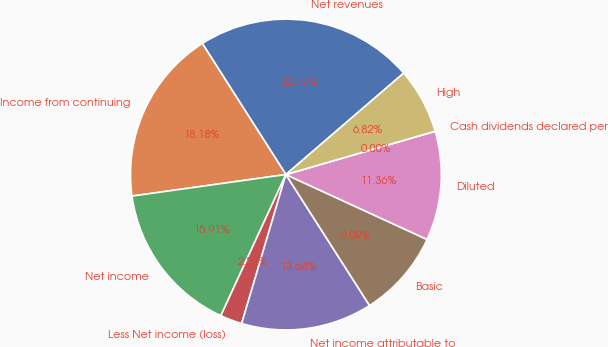Convert chart. <chart><loc_0><loc_0><loc_500><loc_500><pie_chart><fcel>Net revenues<fcel>Income from continuing<fcel>Net income<fcel>Less Net income (loss)<fcel>Net income attributable to<fcel>Basic<fcel>Diluted<fcel>Cash dividends declared per<fcel>High<nl><fcel>22.72%<fcel>18.18%<fcel>15.91%<fcel>2.28%<fcel>13.64%<fcel>9.09%<fcel>11.36%<fcel>0.0%<fcel>6.82%<nl></chart> 